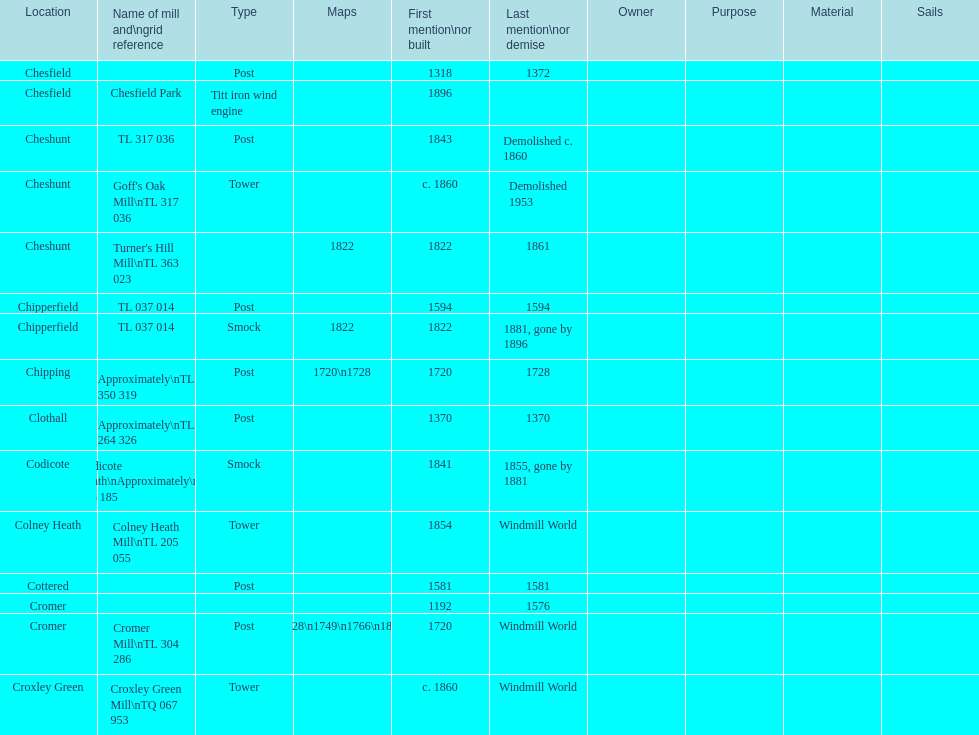How many locations have or had at least 2 windmills? 4. 